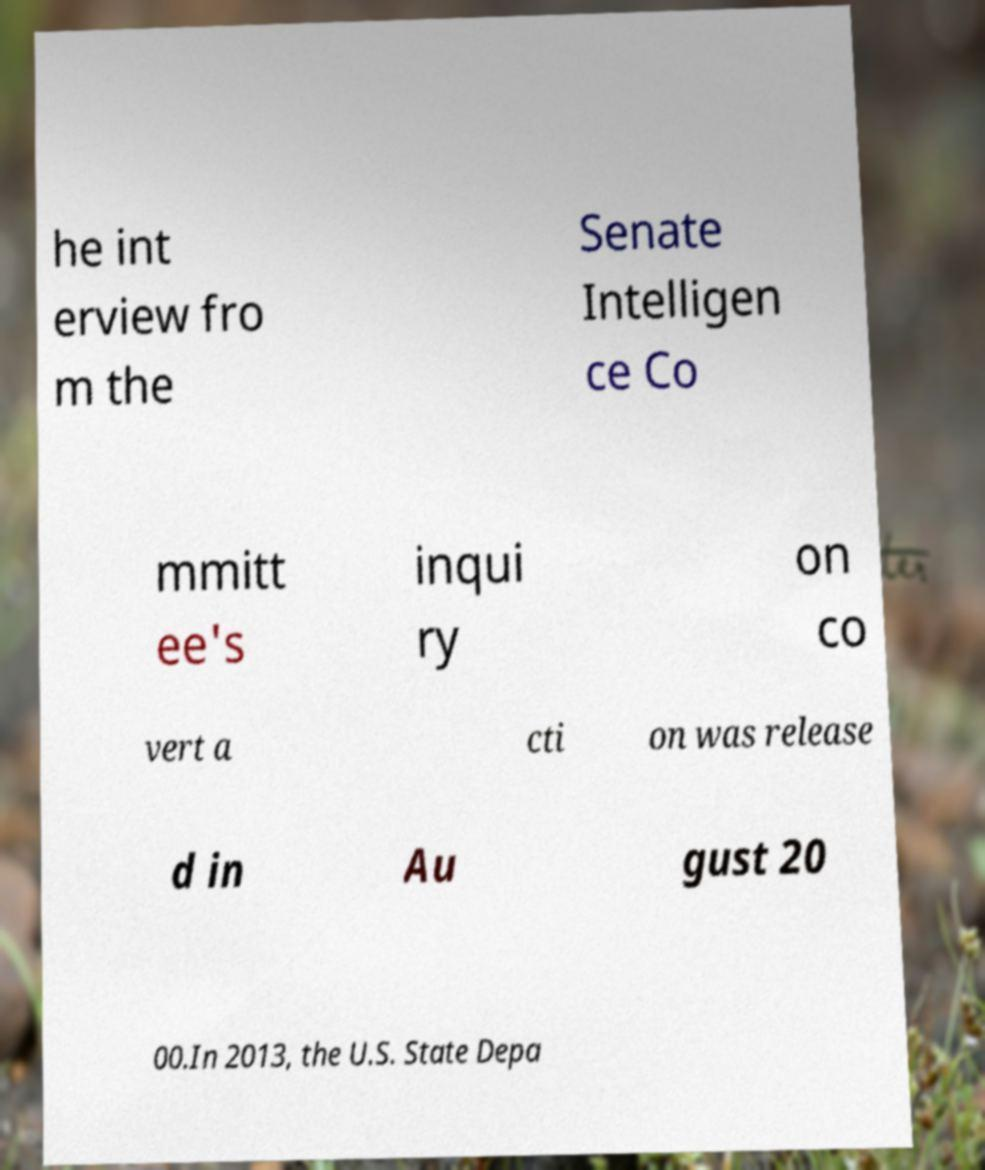Can you read and provide the text displayed in the image?This photo seems to have some interesting text. Can you extract and type it out for me? he int erview fro m the Senate Intelligen ce Co mmitt ee's inqui ry on co vert a cti on was release d in Au gust 20 00.In 2013, the U.S. State Depa 